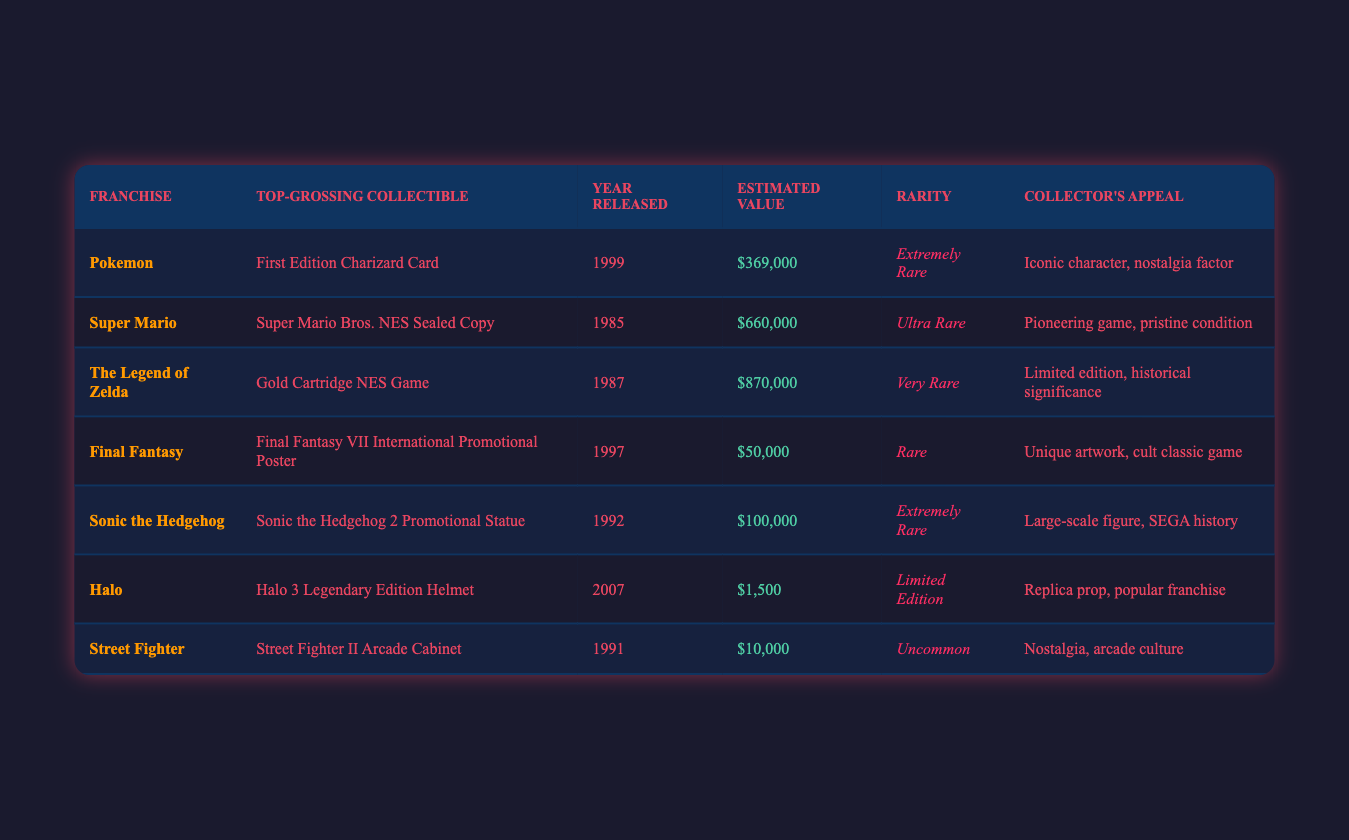What is the top-grossing collectible from The Legend of Zelda franchise? The table lists the top-grossing collectibles by franchise. Looking at the row for The Legend of Zelda, the top-grossing collectible is the Gold Cartridge NES Game.
Answer: Gold Cartridge NES Game Which collectible has the highest estimated value? By comparing the "Estimated Value" column, the values are $369,000 for Pokemon, $660,000 for Super Mario, $870,000 for The Legend of Zelda, $50,000 for Final Fantasy, $100,000 for Sonic the Hedgehog, $1,500 for Halo, and $10,000 for Street Fighter. The highest value is $870,000 from The Legend of Zelda.
Answer: $870,000 Is the First Edition Charizard Card considered rare? The "Rarity" column lists the First Edition Charizard Card as "Extremely Rare." Since it is categorized as extremely rare, the answer is yes.
Answer: Yes What is the estimated value difference between the Super Mario collectible and the Sonic the Hedgehog collectible? The estimated value of the Super Mario collectible is $660,000 while the Sonic the Hedgehog collectible is $100,000. Subtracting these values gives $660,000 - $100,000 = $560,000.
Answer: $560,000 What year was the Final Fantasy VII International Promotional Poster released? In the Final Fantasy row of the table, the Year Released is specified as 1997.
Answer: 1997 How many collectibles are from the 1990s? The table indicates the years of the collectibles: 1999 (Pokemon), 1985 (Super Mario), 1987 (The Legend of Zelda), 1997 (Final Fantasy), 1992 (Sonic the Hedgehog), 2007 (Halo), and 1991 (Street Fighter). The years 1990s are 1999, 1997, 1992, and 1991. Counting these gives 4 collectibles from the 1990s.
Answer: 4 Which franchise has a collectible valued over $600,000? Referring to the "Estimated Value" column, the collectible from The Legend of Zelda is valued at $870,000, and Super Mario is at $660,000. Therefore, both The Legend of Zelda and Super Mario have collectibles valued over $600,000.
Answer: The Legend of Zelda and Super Mario Among the collectibles listed, which one is a limited edition? Only the Halo collectible is classified as "Limited Edition" in the "Rarity" column. Other collectibles have different rarity classifications.
Answer: Halo 3 Legendary Edition Helmet What is the collector's appeal for the top-grossing collectible from the Super Mario franchise? The "Collector's Appeal" for the Super Mario Bros. NES Sealed Copy is described as "Pioneering game, pristine condition."
Answer: Pioneering game, pristine condition 